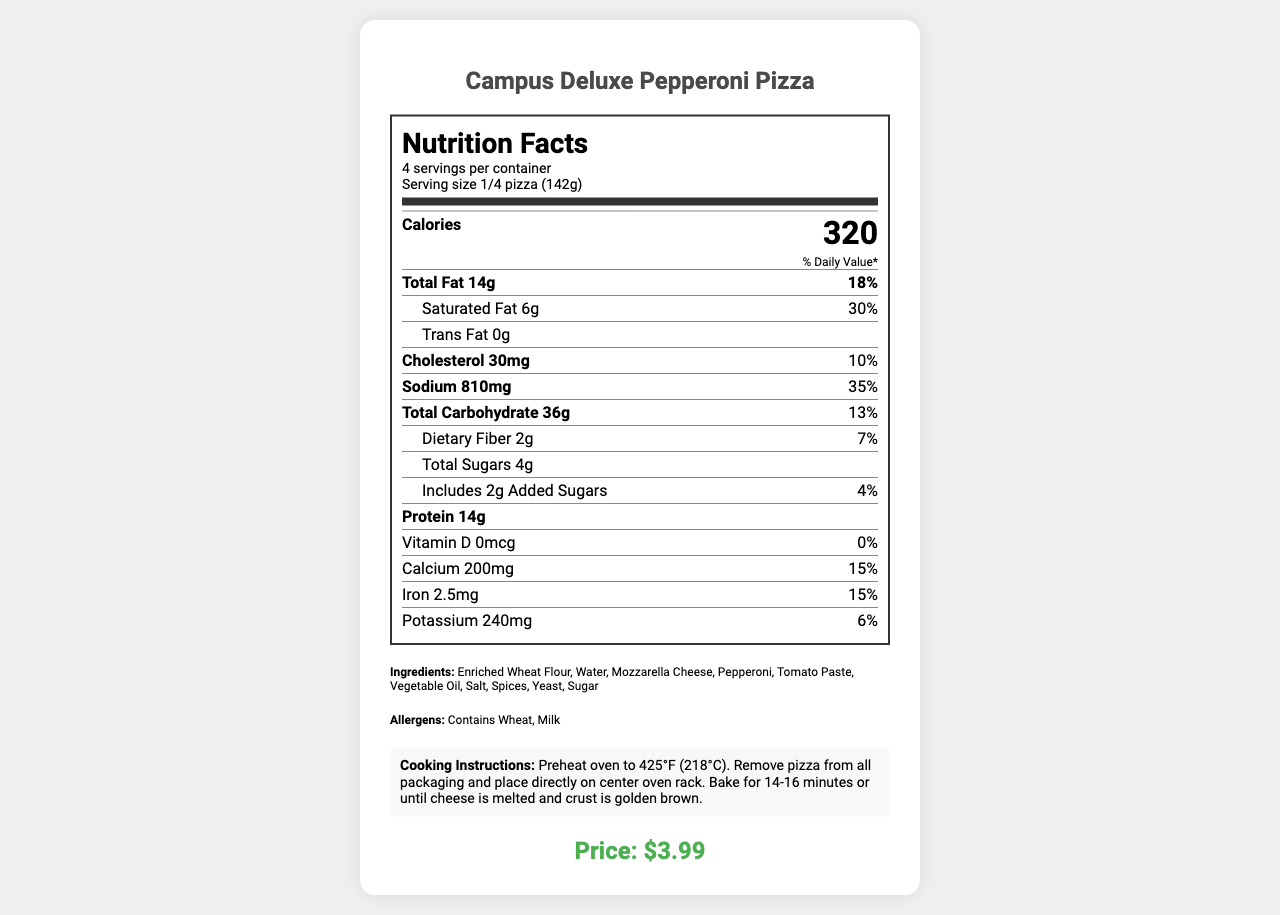what is the serving size? The serving size is specified as "1/4 pizza (142g)" in the document.
Answer: 1/4 pizza (142g) how many servings are in one container? The document states "4 servings per container."
Answer: 4 what is the amount of total fat in one serving? The document lists "Total Fat 14g" for a serving size of 1/4 pizza (142g).
Answer: 14g how much calcium is in one serving? The document specifies "Calcium 200mg" for one serving.
Answer: 200mg what are the allergens mentioned? The document lists "Contains Wheat, Milk" under the allergens section.
Answer: Contains Wheat, Milk what is the calorie content per serving? The document clearly states "Calories 320" in the nutrition facts section.
Answer: 320 how many grams of protein does one serving have? The document lists "Protein 14g" for one serving.
Answer: 14g what is the storage instruction for the product? The document mentions "Keep frozen" under storage.
Answer: Keep frozen if I eat half the pizza, how many milligrams of sodium would I consume? A. 405mg B. 810mg C. 1620mg D. 3240mg One serving size contains 810mg of sodium. Since there are 2 servings in half a pizza (half of 4), the sodium content would be 810mg × 2 = 1620mg.
Answer: C. 1620mg how should you cook this pizza? A. Microwave for 10 minutes B. Preheat oven to 425°F (218°C), bake for 14-16 minutes C. Grill for 5 minutes on each side D. Refrigerate for 24 hours The document specifies the cooking instructions as "Preheat oven to 425°F (218°C). Remove pizza from all packaging and place directly on center oven rack. Bake for 14-16 minutes or until cheese is melted and crust is golden brown."
Answer: B. Preheat oven to 425°F (218°C), bake for 14-16 minutes does this product contain any trans fat? The document shows "Trans Fat 0g" which means it contains no trans fat.
Answer: No can the document tell us where the ingredients were sourced from? The document does not provide any information about the source of the ingredients.
Answer: Not enough information provide a summary of the document. The document is a detailed nutrition label for Campus Deluxe Pepperoni Pizza, including serving details, nutrient breakdown, ingredient list, allergen warnings, cooking and storage instructions, price, and manufacturer details. It covers all necessary aspects one would need to understand the nutritional value and handling of the product.
Answer: The document presents the nutrition facts for Campus Deluxe Pepperoni Pizza, detailing serving size, calories, and nutrient content per serving. It includes ingredients, allergens, cooking instructions, storage instructions, price, and manufacturer information. The nutritional label shows values for fat, cholesterol, sodium, carbohydrates, sugars, fiber, protein, vitamins, and minerals. 